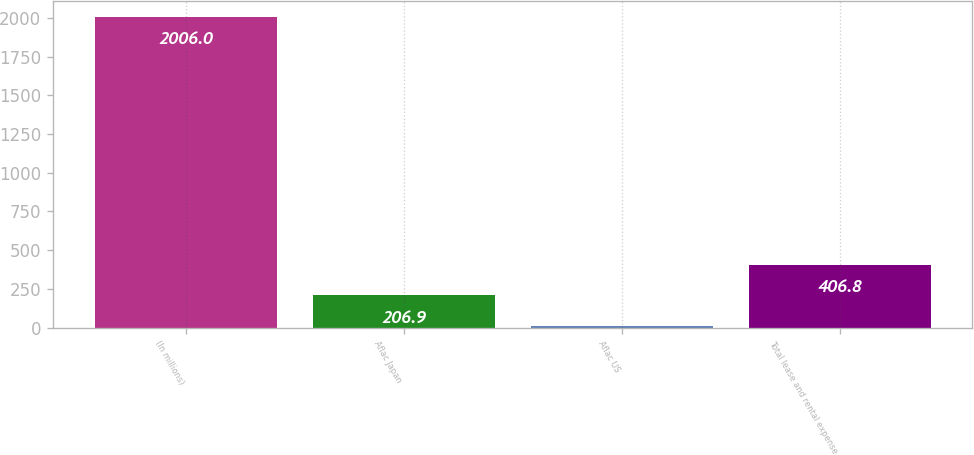Convert chart. <chart><loc_0><loc_0><loc_500><loc_500><bar_chart><fcel>(In millions)<fcel>Aflac Japan<fcel>Aflac US<fcel>Total lease and rental expense<nl><fcel>2006<fcel>206.9<fcel>7<fcel>406.8<nl></chart> 